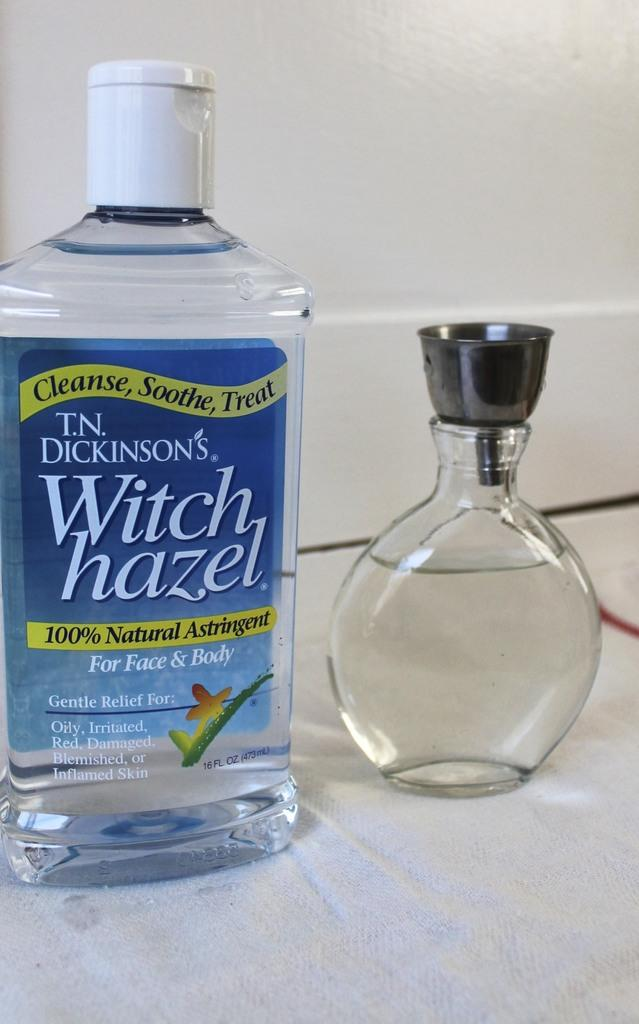Provide a one-sentence caption for the provided image. A bottle of T.N. Dickinson's Witch hazel next to a small vase. 